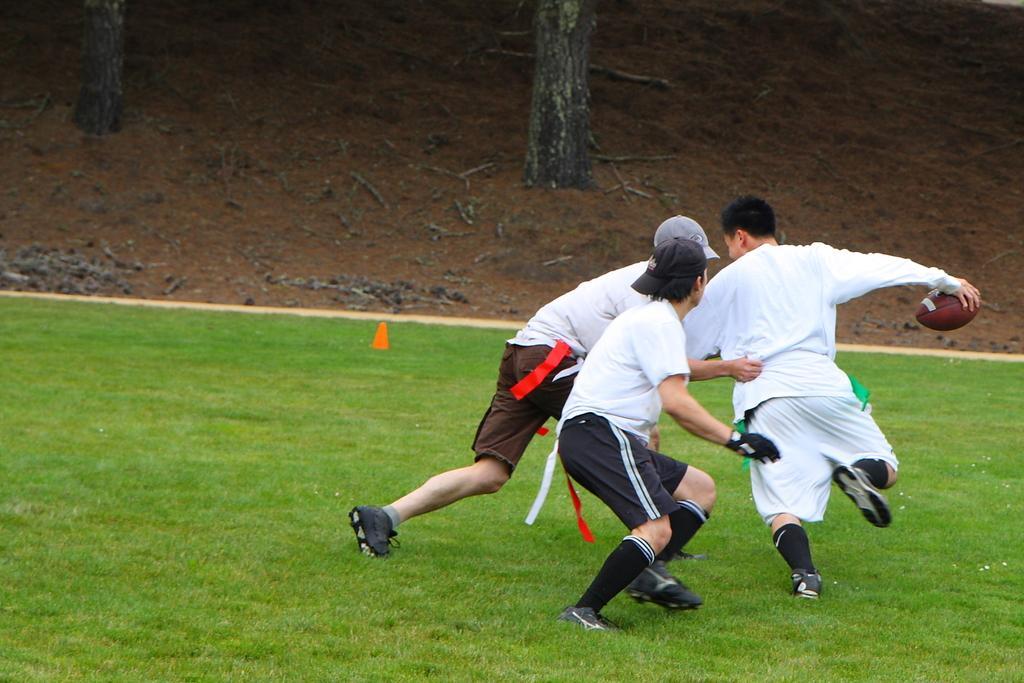In one or two sentences, can you explain what this image depicts? In this image we can see a few people playing rugby game and also we can see the grass and some wood on the ground. 